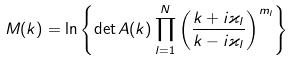<formula> <loc_0><loc_0><loc_500><loc_500>M ( k ) = \ln \left \{ \det A ( k ) \prod _ { l = 1 } ^ { N } \left ( \frac { k + i \varkappa _ { l } } { k - i \varkappa _ { l } } \right ) ^ { m _ { l } } \right \}</formula> 